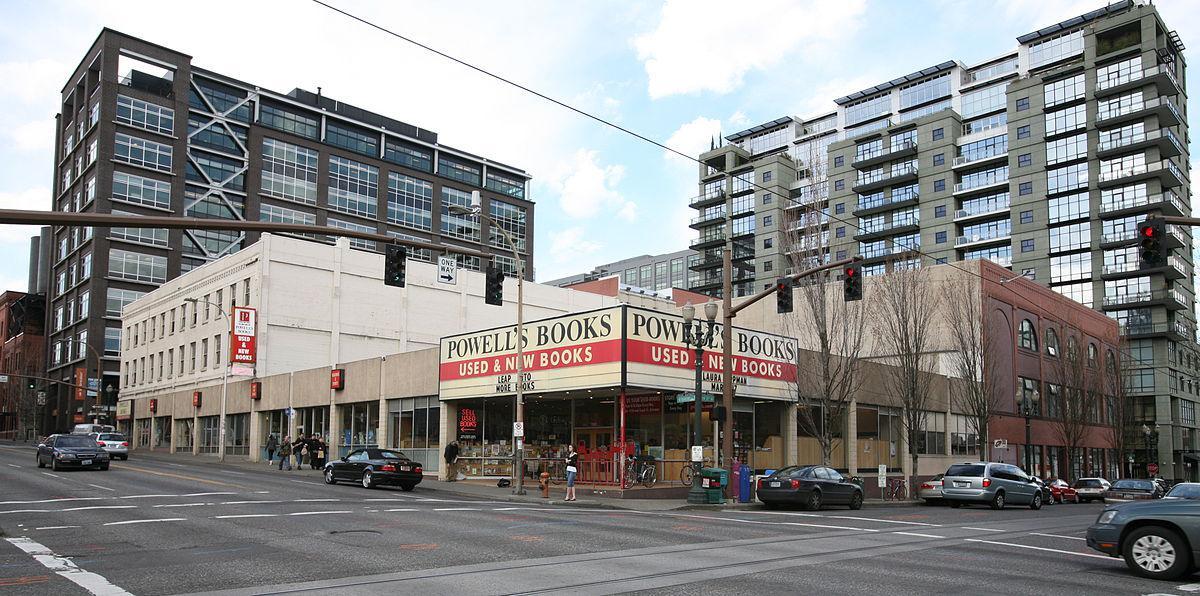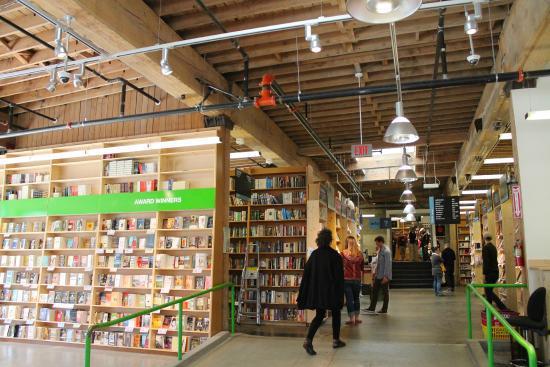The first image is the image on the left, the second image is the image on the right. Considering the images on both sides, is "There is a single woman with black hair who has sat down to read near at least one other shelf of books." valid? Answer yes or no. No. The first image is the image on the left, the second image is the image on the right. Given the left and right images, does the statement "A person is sitting down." hold true? Answer yes or no. No. 